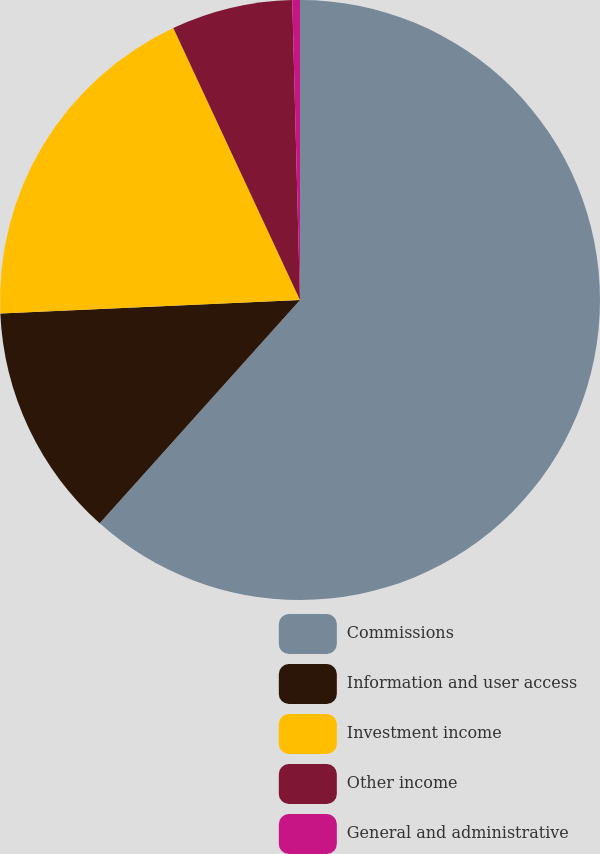Convert chart. <chart><loc_0><loc_0><loc_500><loc_500><pie_chart><fcel>Commissions<fcel>Information and user access<fcel>Investment income<fcel>Other income<fcel>General and administrative<nl><fcel>61.64%<fcel>12.65%<fcel>18.78%<fcel>6.53%<fcel>0.41%<nl></chart> 